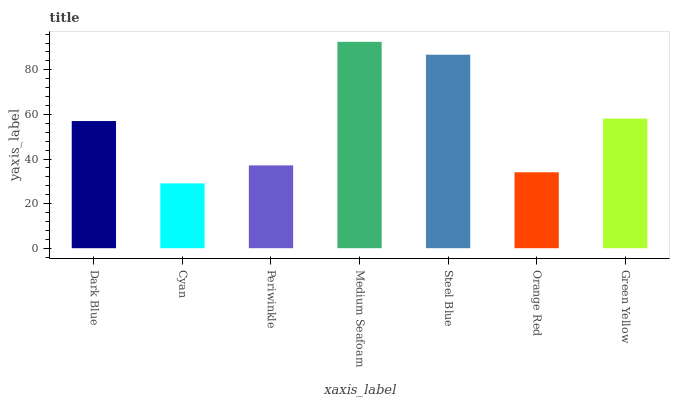Is Cyan the minimum?
Answer yes or no. Yes. Is Medium Seafoam the maximum?
Answer yes or no. Yes. Is Periwinkle the minimum?
Answer yes or no. No. Is Periwinkle the maximum?
Answer yes or no. No. Is Periwinkle greater than Cyan?
Answer yes or no. Yes. Is Cyan less than Periwinkle?
Answer yes or no. Yes. Is Cyan greater than Periwinkle?
Answer yes or no. No. Is Periwinkle less than Cyan?
Answer yes or no. No. Is Dark Blue the high median?
Answer yes or no. Yes. Is Dark Blue the low median?
Answer yes or no. Yes. Is Orange Red the high median?
Answer yes or no. No. Is Green Yellow the low median?
Answer yes or no. No. 